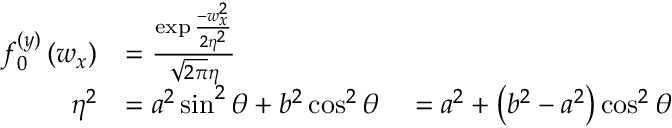Convert formula to latex. <formula><loc_0><loc_0><loc_500><loc_500>\begin{array} { r l } { f _ { 0 } ^ { ( y ) } \left ( w _ { x } \right ) } & { = \frac { \exp \frac { - w _ { x } ^ { 2 } } { 2 \eta ^ { 2 } } } { \sqrt { 2 \pi } \eta } } \\ { \eta ^ { 2 } } & { = a ^ { 2 } \sin ^ { 2 } \theta + b ^ { 2 } \cos ^ { 2 } \theta \quad = a ^ { 2 } + \left ( b ^ { 2 } - a ^ { 2 } \right ) \cos ^ { 2 } \theta } \end{array}</formula> 